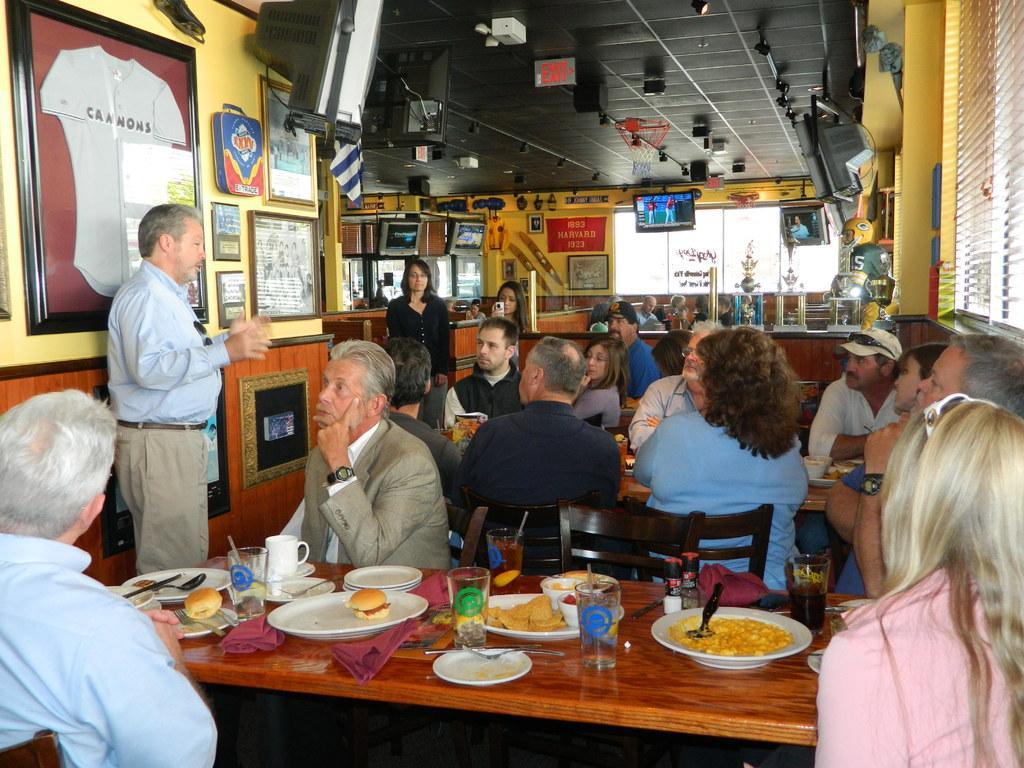How would you summarize this image in a sentence or two? In this picture we can see some people sitting on chairs in front of tables, there are some plates, glasses, clothes, a cup and a saucer present on this table, we can see some food and spoons present in theses plates, there are two persons standing here, in the background there is a wall, we can see some photo frames on the wall, there are two screens here, we can see ceiling at the top of the picture, on the right side there is a window blind. 